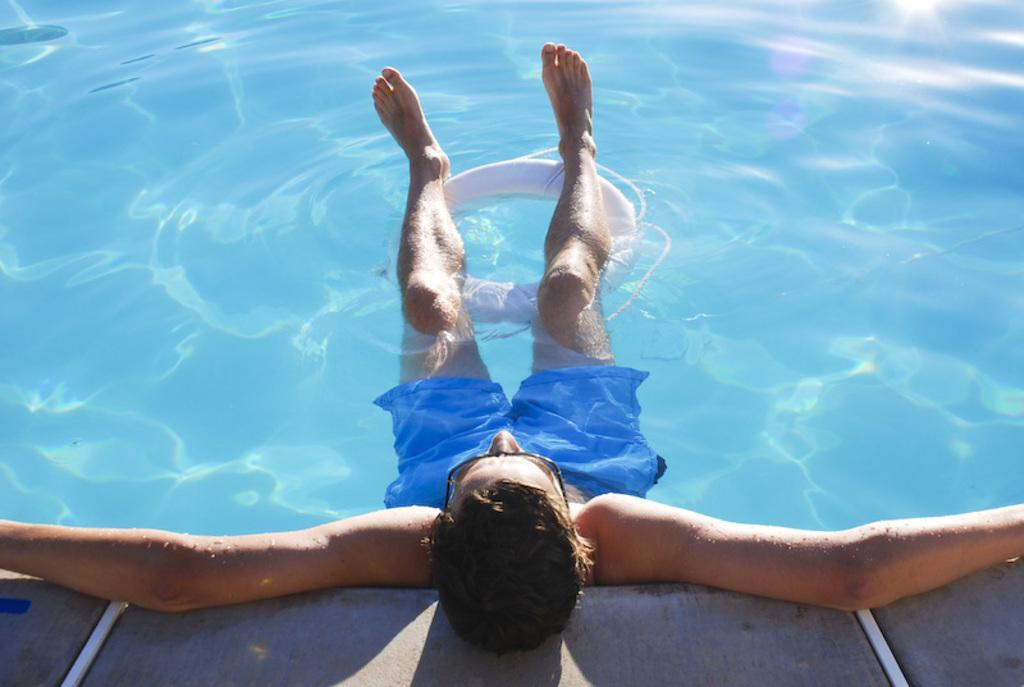What is located in the foreground of the picture? There is a water pool in the foreground of the picture. What is the person in the picture doing? A person is relaxing in the water pool. What safety device is present in the water pool? There is a lifebuoy in the water pool. How would you describe the bottom of the pool? The bottom of the pool is visible and is described as a floor. What type of locket is the actor wearing while reading in the image? There is no actor or reading depicted in the image; it features a person relaxing in a water pool with a lifebuoy. 